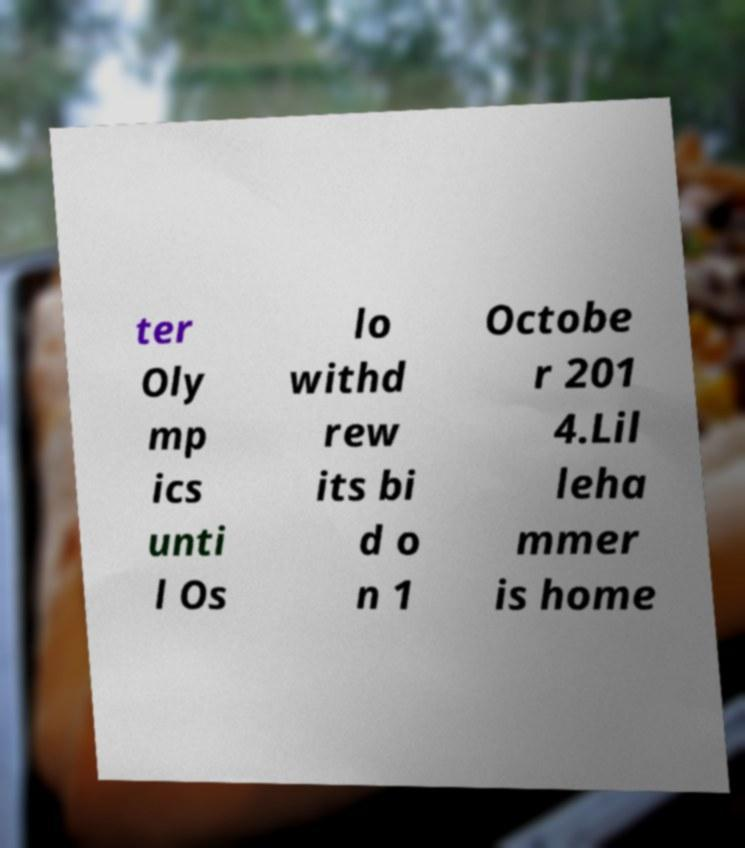I need the written content from this picture converted into text. Can you do that? ter Oly mp ics unti l Os lo withd rew its bi d o n 1 Octobe r 201 4.Lil leha mmer is home 